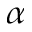<formula> <loc_0><loc_0><loc_500><loc_500>\alpha</formula> 